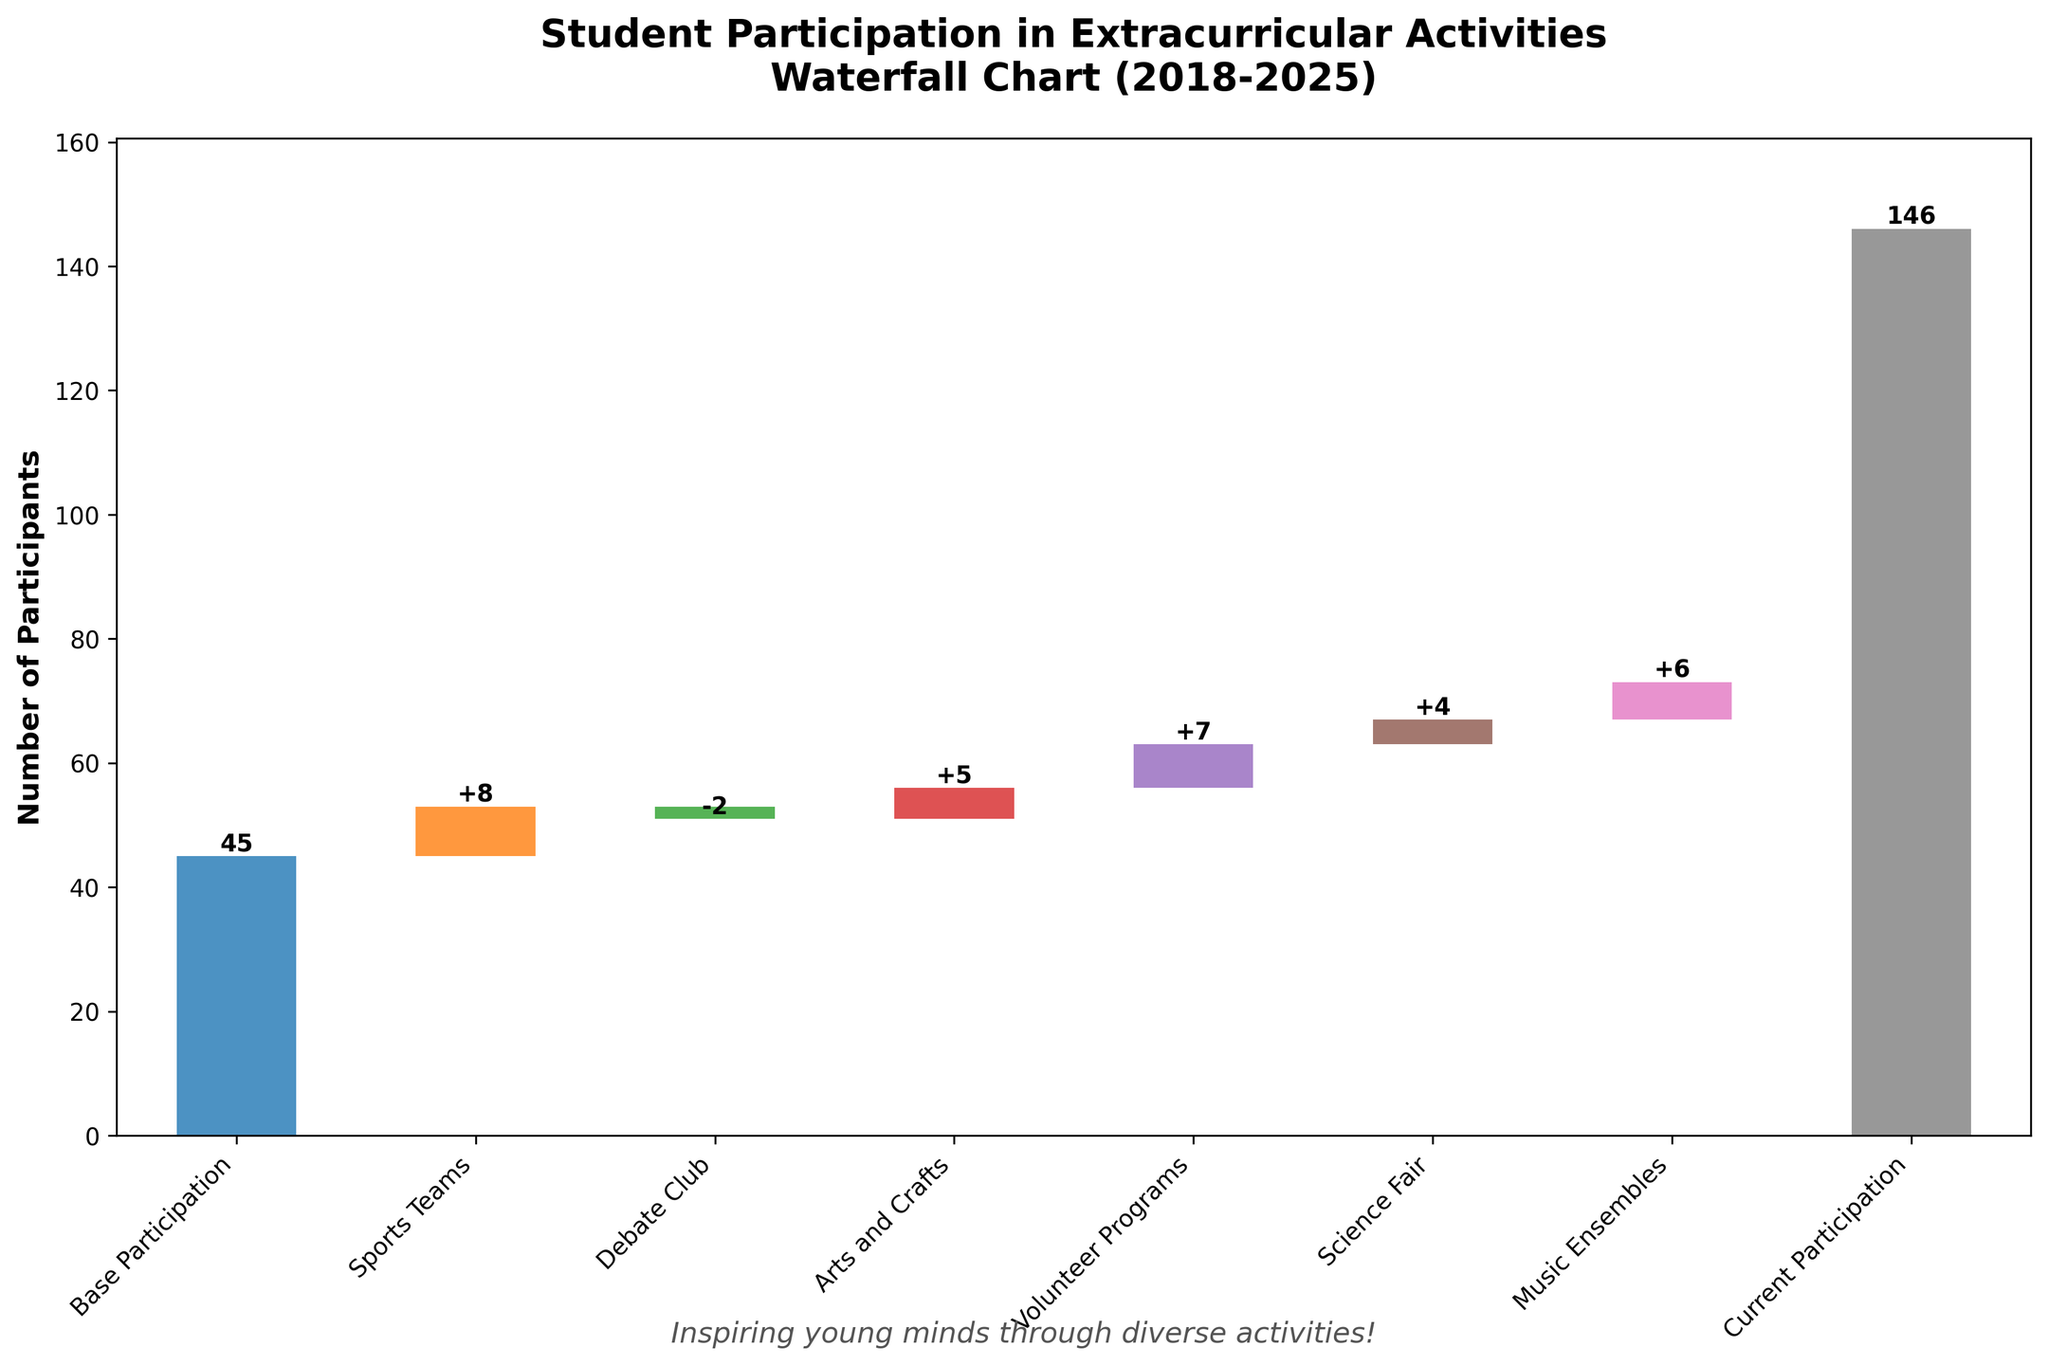What is the number of participants in the base year, 2018? The value for base participation in 2018 is directly labeled on the figure as the starting point.
Answer: 45 How much did participation in sports teams change in 2019? The change in sports teams' participation in 2019 is shown as +8 on the figure.
Answer: +8 How many participants were added in total from Volunteer Programs and Science Fair combined? The changes for Volunteer Programs and Science Fair are +7 and +4 respectively. Summing them up gives 7 + 4 = 11.
Answer: 11 Which activity in the chart shows a decrease in participation? By observing the bars, the only negative change is seen in the Debate Club for the year 2020, with a change of -2.
Answer: Debate Club How many activities resulted in an increase in participation? By inspecting the changes: Sports Teams (+8), Arts and Crafts (+5), Volunteer Programs (+7), Science Fair (+4), and Music Ensembles (+6), we count 5 activities with positive changes.
Answer: 5 What is the final number of participants in 2025? The figure labels the final value as 'Current Participation' in 2025, displaying 73.
Answer: 73 What is the cumulative participation after the addition of Volunteer Programs in 2022? The cumulative participation after Volunteer Programs in 2022 is the sum of all changes up to that point: 45 (Base) + 8 (Sports Teams) - 2 (Debate Club) + 5 (Arts and Crafts) + 7 (Volunteer Programs). So, 45 + 8 - 2 + 5 + 7 = 63.
Answer: 63 How does the change in participation for Music Ensembles in 2024 compare to that for Arts and Crafts in 2021? The increase in participation for Music Ensembles in 2024 is +6, and for Arts and Crafts in 2021, it is +5. Hence, Music Ensembles had a greater increase than Arts and Crafts by 1.
Answer: Music Ensembles increased more by 1 What activity had the highest positive change in participation and what was its value? By examining all positive changes, the highest increase is in Sports Teams with +8 in 2019.
Answer: Sports Teams, +8 What was the total number of additions after the base year and before the final participation in 2025? Summing up all positive changes: +8 (Sports Teams) - 2 (Debate Club) + 5 (Arts and Crafts) + 7 (Volunteer Programs) + 4 (Science Fair) + 6 (Music Ensembles), the total change is 28 (additions minus the one decrease of 2).
Answer: 28 